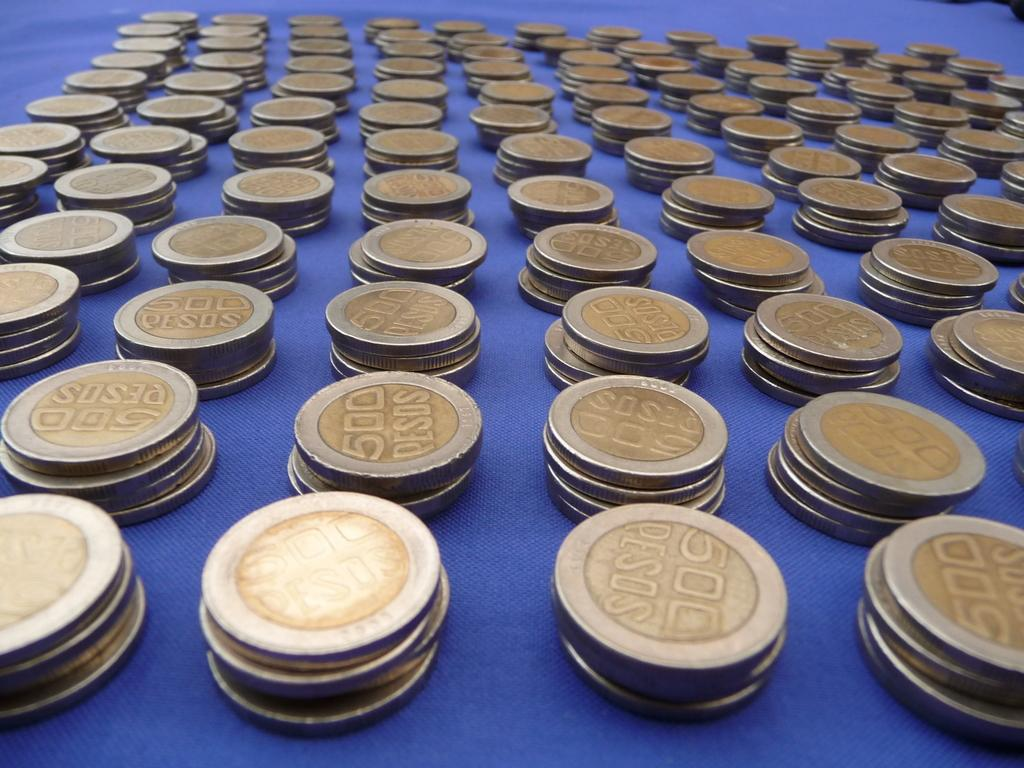<image>
Summarize the visual content of the image. Many stacks of gold coins lined up in rows with printed pesos on each coin. 